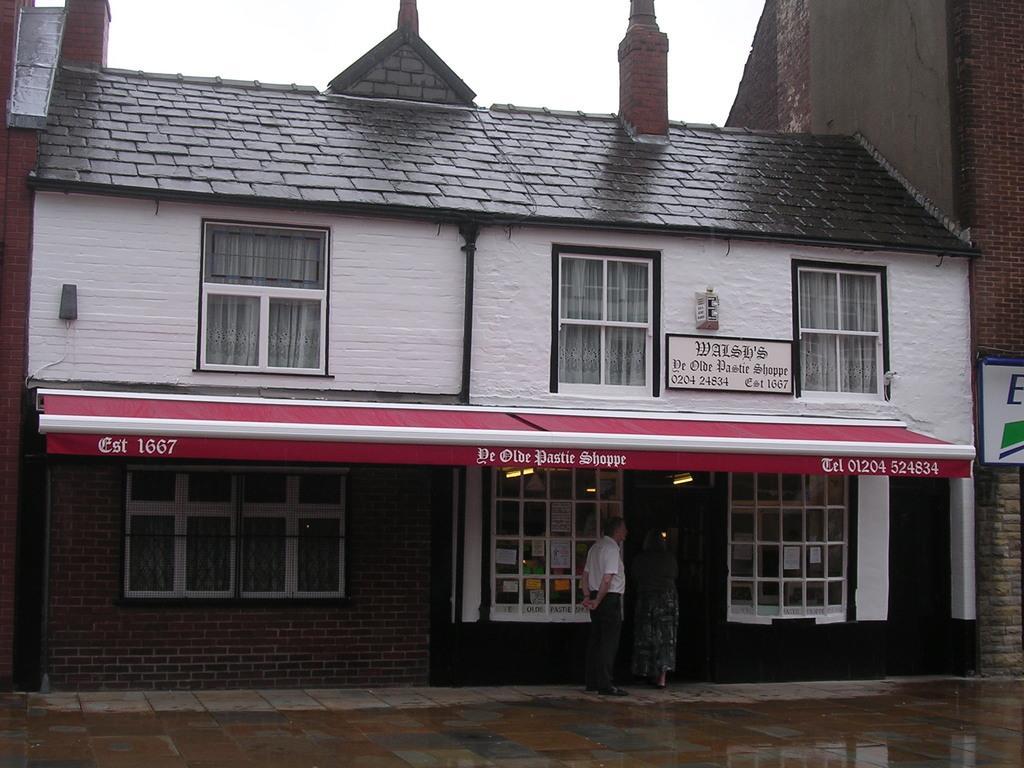Could you give a brief overview of what you see in this image? In this image we can see water on the road, we can see this person is standing here, we can see building with glass windows, board here. Here we can see the brick building and the sky in the background. 